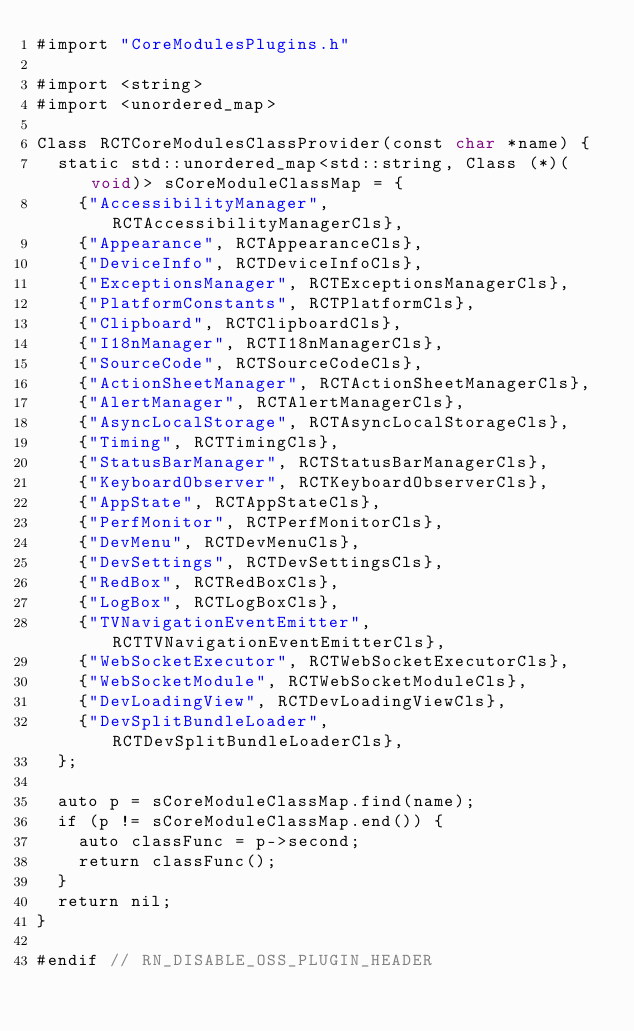<code> <loc_0><loc_0><loc_500><loc_500><_ObjectiveC_>#import "CoreModulesPlugins.h"

#import <string>
#import <unordered_map>

Class RCTCoreModulesClassProvider(const char *name) {
  static std::unordered_map<std::string, Class (*)(void)> sCoreModuleClassMap = {
    {"AccessibilityManager", RCTAccessibilityManagerCls},
    {"Appearance", RCTAppearanceCls},
    {"DeviceInfo", RCTDeviceInfoCls},
    {"ExceptionsManager", RCTExceptionsManagerCls},
    {"PlatformConstants", RCTPlatformCls},
    {"Clipboard", RCTClipboardCls},
    {"I18nManager", RCTI18nManagerCls},
    {"SourceCode", RCTSourceCodeCls},
    {"ActionSheetManager", RCTActionSheetManagerCls},
    {"AlertManager", RCTAlertManagerCls},
    {"AsyncLocalStorage", RCTAsyncLocalStorageCls},
    {"Timing", RCTTimingCls},
    {"StatusBarManager", RCTStatusBarManagerCls},
    {"KeyboardObserver", RCTKeyboardObserverCls},
    {"AppState", RCTAppStateCls},
    {"PerfMonitor", RCTPerfMonitorCls},
    {"DevMenu", RCTDevMenuCls},
    {"DevSettings", RCTDevSettingsCls},
    {"RedBox", RCTRedBoxCls},
    {"LogBox", RCTLogBoxCls},
    {"TVNavigationEventEmitter", RCTTVNavigationEventEmitterCls},
    {"WebSocketExecutor", RCTWebSocketExecutorCls},
    {"WebSocketModule", RCTWebSocketModuleCls},
    {"DevLoadingView", RCTDevLoadingViewCls},
    {"DevSplitBundleLoader", RCTDevSplitBundleLoaderCls},
  };

  auto p = sCoreModuleClassMap.find(name);
  if (p != sCoreModuleClassMap.end()) {
    auto classFunc = p->second;
    return classFunc();
  }
  return nil;
}

#endif // RN_DISABLE_OSS_PLUGIN_HEADER
</code> 